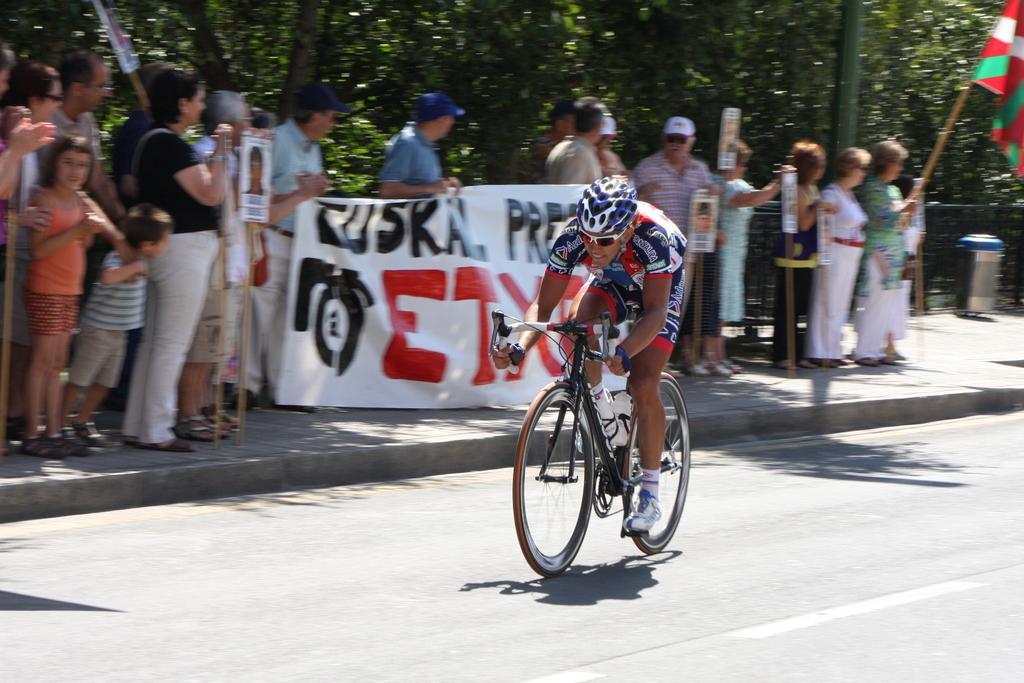Describe this image in one or two sentences. The picture is outside a road. a man is riding a bicycle he is wearing a helmet. Beside the road many people are standing they are holding placard, banner,flag. In the right there is a dustbin. In the background there are trees. 